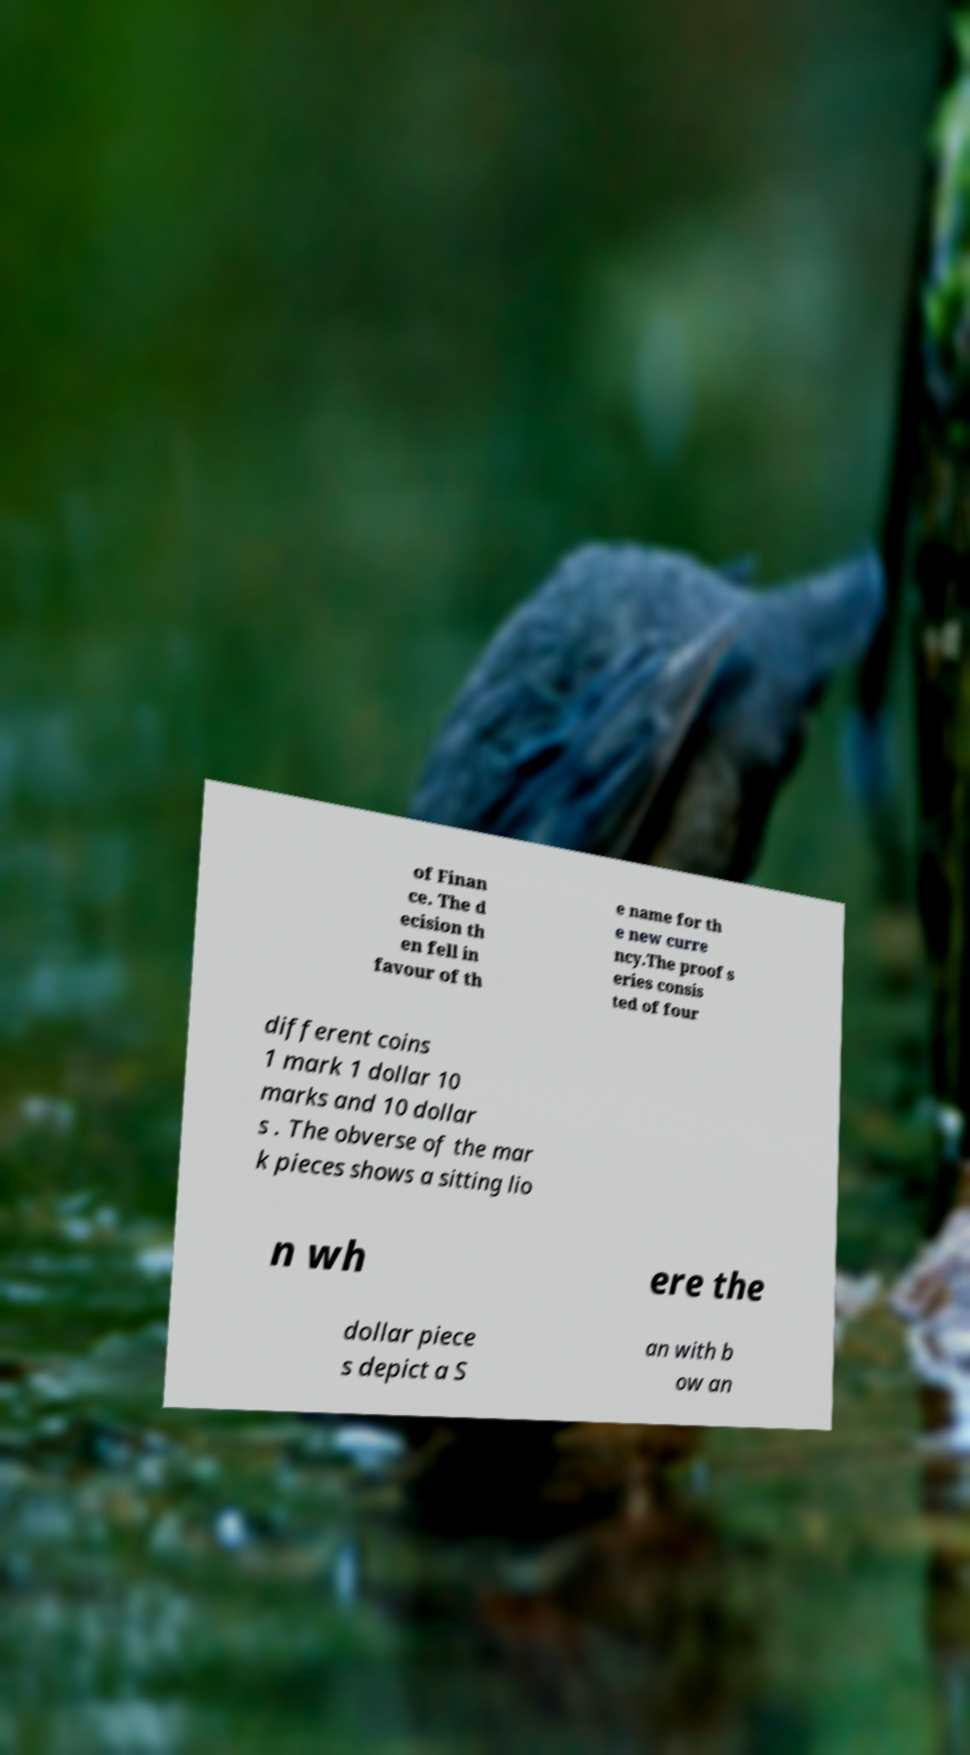What messages or text are displayed in this image? I need them in a readable, typed format. of Finan ce. The d ecision th en fell in favour of th e name for th e new curre ncy.The proof s eries consis ted of four different coins 1 mark 1 dollar 10 marks and 10 dollar s . The obverse of the mar k pieces shows a sitting lio n wh ere the dollar piece s depict a S an with b ow an 